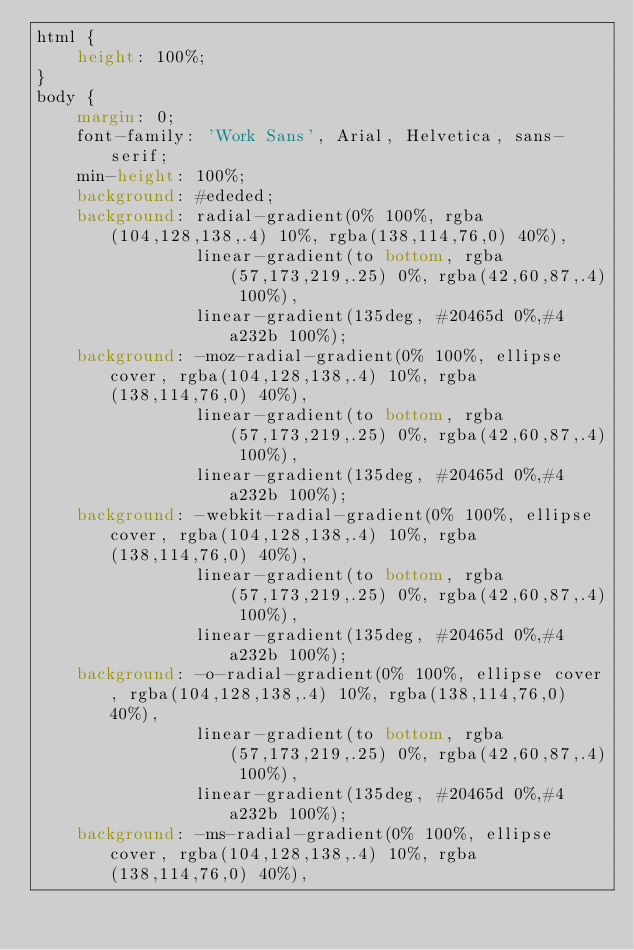<code> <loc_0><loc_0><loc_500><loc_500><_CSS_>html {
    height: 100%;
}
body {
    margin: 0;
    font-family: 'Work Sans', Arial, Helvetica, sans-serif;
    min-height: 100%;
    background: #ededed;
    background: radial-gradient(0% 100%, rgba(104,128,138,.4) 10%, rgba(138,114,76,0) 40%),
                linear-gradient(to bottom, rgba(57,173,219,.25) 0%, rgba(42,60,87,.4) 100%),
                linear-gradient(135deg, #20465d 0%,#4a232b 100%);
    background: -moz-radial-gradient(0% 100%, ellipse cover, rgba(104,128,138,.4) 10%, rgba(138,114,76,0) 40%),
                linear-gradient(to bottom, rgba(57,173,219,.25) 0%, rgba(42,60,87,.4) 100%),
                linear-gradient(135deg, #20465d 0%,#4a232b 100%);
    background: -webkit-radial-gradient(0% 100%, ellipse cover, rgba(104,128,138,.4) 10%, rgba(138,114,76,0) 40%),
                linear-gradient(to bottom, rgba(57,173,219,.25) 0%, rgba(42,60,87,.4) 100%),
                linear-gradient(135deg, #20465d 0%,#4a232b 100%);
    background: -o-radial-gradient(0% 100%, ellipse cover, rgba(104,128,138,.4) 10%, rgba(138,114,76,0) 40%),
                linear-gradient(to bottom, rgba(57,173,219,.25) 0%, rgba(42,60,87,.4) 100%),
                linear-gradient(135deg, #20465d 0%,#4a232b 100%);
    background: -ms-radial-gradient(0% 100%, ellipse cover, rgba(104,128,138,.4) 10%, rgba(138,114,76,0) 40%),</code> 